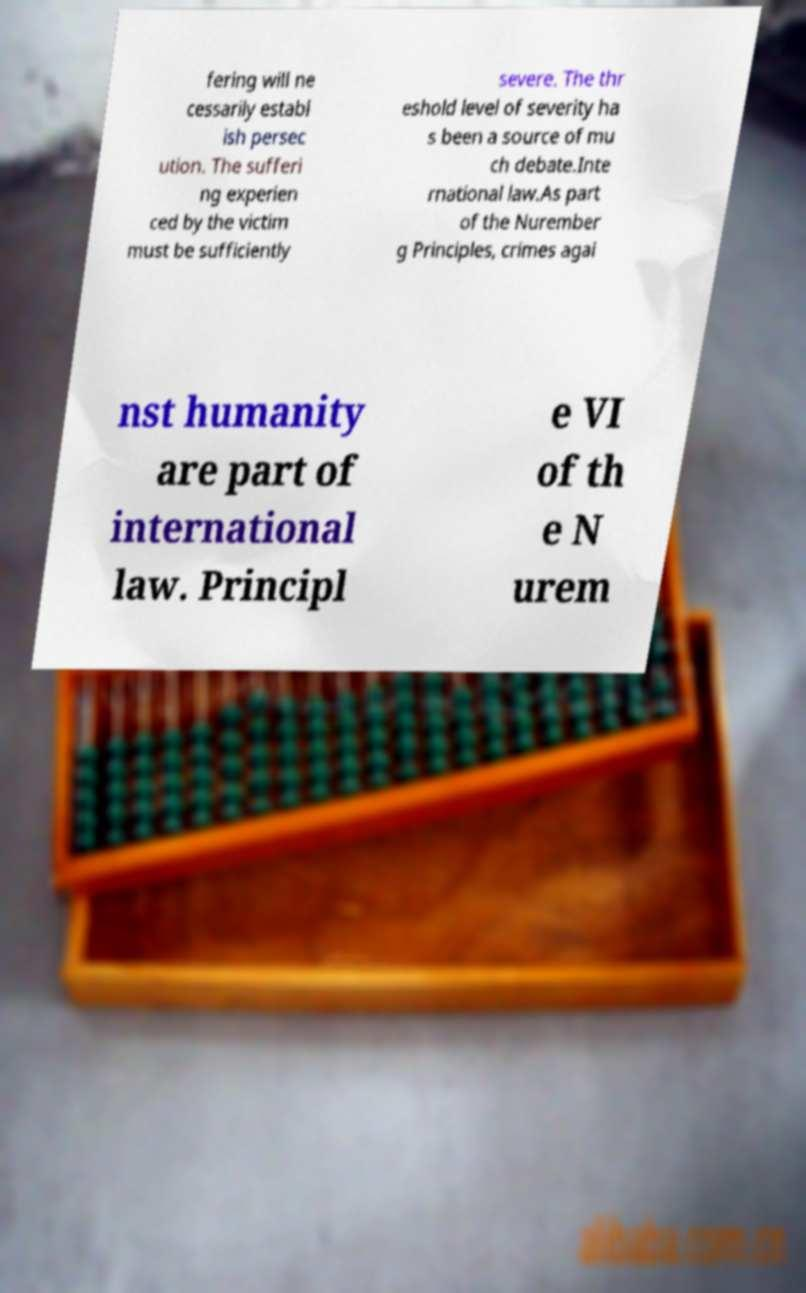Please read and relay the text visible in this image. What does it say? fering will ne cessarily establ ish persec ution. The sufferi ng experien ced by the victim must be sufficiently severe. The thr eshold level of severity ha s been a source of mu ch debate.Inte rnational law.As part of the Nurember g Principles, crimes agai nst humanity are part of international law. Principl e VI of th e N urem 